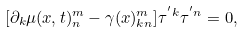Convert formula to latex. <formula><loc_0><loc_0><loc_500><loc_500>[ \partial _ { k } \mu ( x , t ) ^ { m } _ { n } - \gamma ( x ) ^ { m } _ { k n } ] \tau ^ { ^ { \prime } k } \tau ^ { ^ { \prime } n } = 0 ,</formula> 